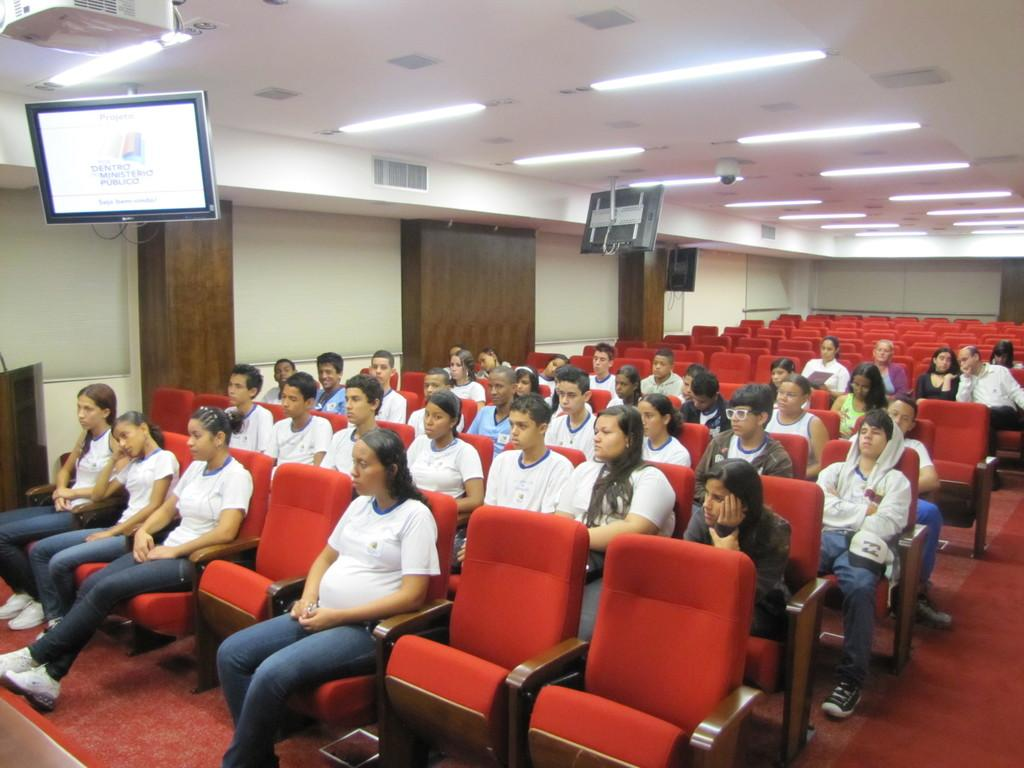What are the people in the image doing? The people in the image are sitting on chairs. What is located at the bottom of the image? There is a mat at the bottom of the image. What is located at the top of the image? There is a camera at the top of the image. What type of equipment is present in the image? There are lights and TVs in the image. What type of church can be seen in the image? There is no church present in the image. How many airplanes are visible in the image? There are no airplanes visible in the image. 